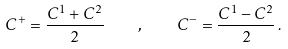<formula> <loc_0><loc_0><loc_500><loc_500>C ^ { + } = \frac { C ^ { 1 } + C ^ { 2 } } { 2 } \quad , \quad C ^ { - } = \frac { C ^ { 1 } - C ^ { 2 } } { 2 } \, .</formula> 